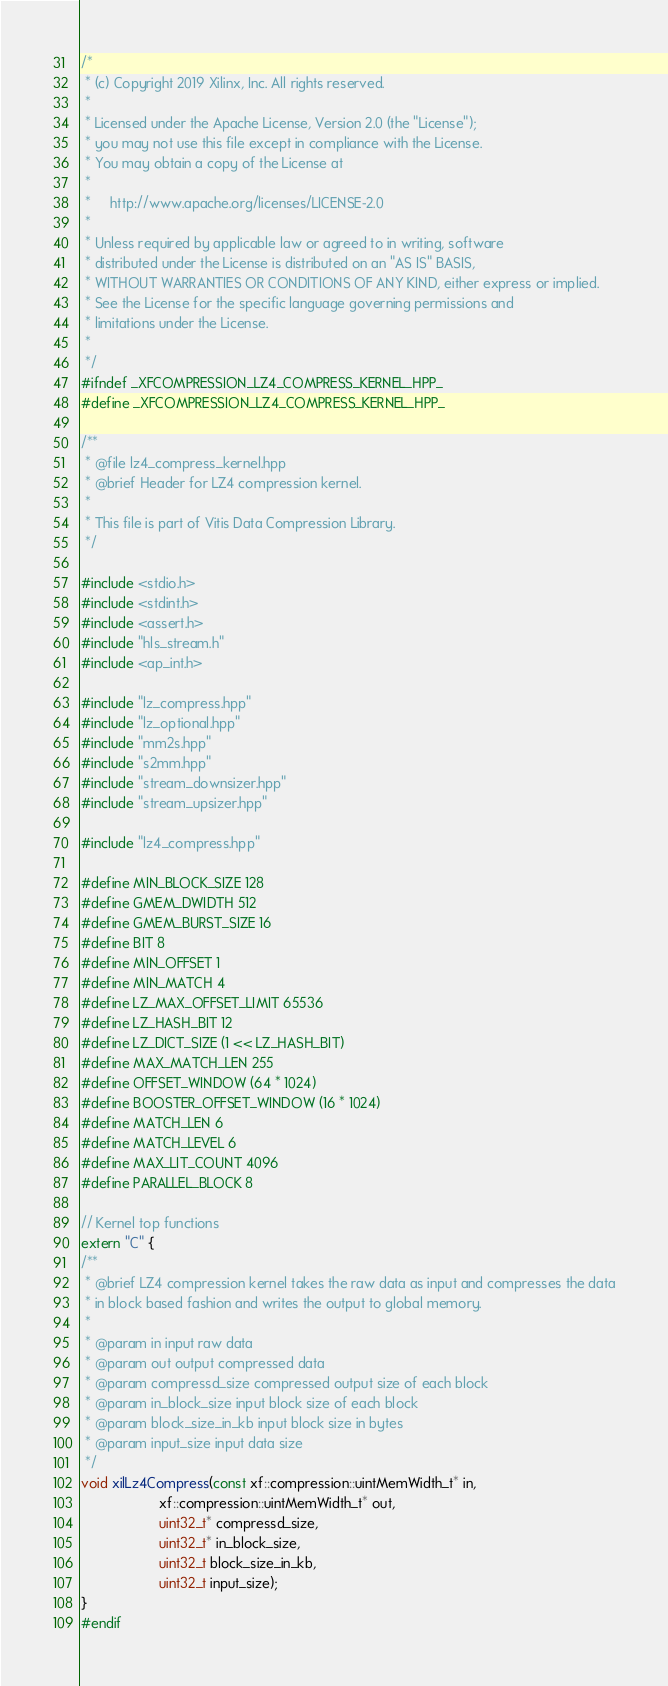<code> <loc_0><loc_0><loc_500><loc_500><_C++_>/*
 * (c) Copyright 2019 Xilinx, Inc. All rights reserved.
 *
 * Licensed under the Apache License, Version 2.0 (the "License");
 * you may not use this file except in compliance with the License.
 * You may obtain a copy of the License at
 *
 *     http://www.apache.org/licenses/LICENSE-2.0
 *
 * Unless required by applicable law or agreed to in writing, software
 * distributed under the License is distributed on an "AS IS" BASIS,
 * WITHOUT WARRANTIES OR CONDITIONS OF ANY KIND, either express or implied.
 * See the License for the specific language governing permissions and
 * limitations under the License.
 *
 */
#ifndef _XFCOMPRESSION_LZ4_COMPRESS_KERNEL_HPP_
#define _XFCOMPRESSION_LZ4_COMPRESS_KERNEL_HPP_

/**
 * @file lz4_compress_kernel.hpp
 * @brief Header for LZ4 compression kernel.
 *
 * This file is part of Vitis Data Compression Library.
 */

#include <stdio.h>
#include <stdint.h>
#include <assert.h>
#include "hls_stream.h"
#include <ap_int.h>

#include "lz_compress.hpp"
#include "lz_optional.hpp"
#include "mm2s.hpp"
#include "s2mm.hpp"
#include "stream_downsizer.hpp"
#include "stream_upsizer.hpp"

#include "lz4_compress.hpp"

#define MIN_BLOCK_SIZE 128
#define GMEM_DWIDTH 512
#define GMEM_BURST_SIZE 16
#define BIT 8
#define MIN_OFFSET 1
#define MIN_MATCH 4
#define LZ_MAX_OFFSET_LIMIT 65536
#define LZ_HASH_BIT 12
#define LZ_DICT_SIZE (1 << LZ_HASH_BIT)
#define MAX_MATCH_LEN 255
#define OFFSET_WINDOW (64 * 1024)
#define BOOSTER_OFFSET_WINDOW (16 * 1024)
#define MATCH_LEN 6
#define MATCH_LEVEL 6
#define MAX_LIT_COUNT 4096
#define PARALLEL_BLOCK 8

// Kernel top functions
extern "C" {
/**
 * @brief LZ4 compression kernel takes the raw data as input and compresses the data
 * in block based fashion and writes the output to global memory.
 *
 * @param in input raw data
 * @param out output compressed data
 * @param compressd_size compressed output size of each block
 * @param in_block_size input block size of each block
 * @param block_size_in_kb input block size in bytes
 * @param input_size input data size
 */
void xilLz4Compress(const xf::compression::uintMemWidth_t* in,
                    xf::compression::uintMemWidth_t* out,
                    uint32_t* compressd_size,
                    uint32_t* in_block_size,
                    uint32_t block_size_in_kb,
                    uint32_t input_size);
}
#endif
</code> 